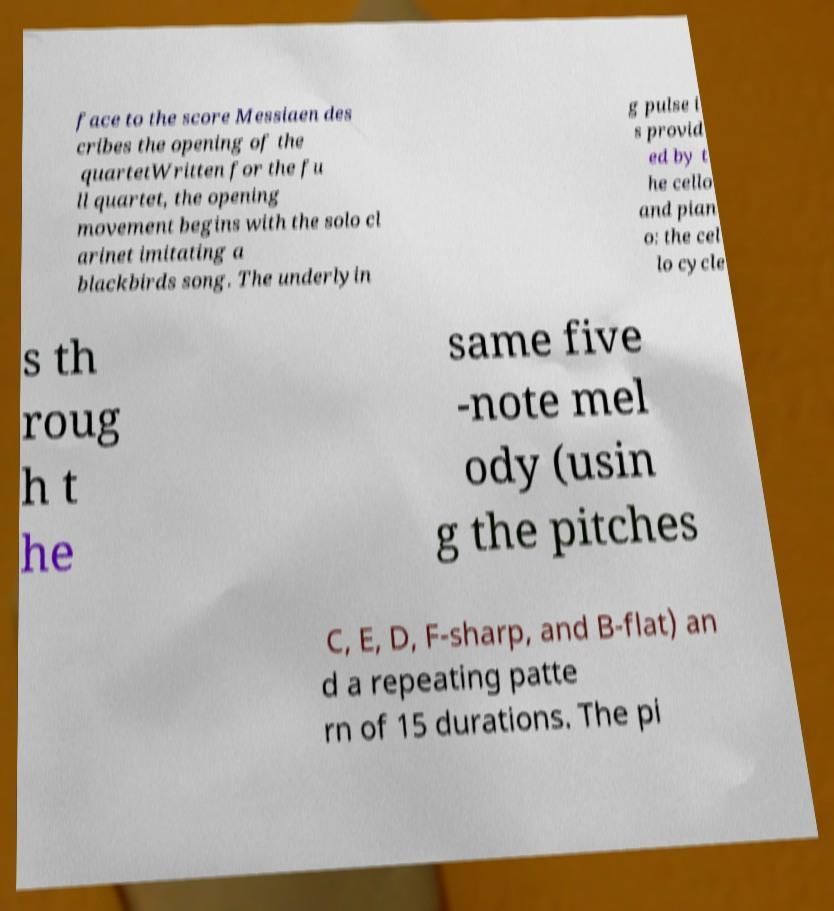Could you assist in decoding the text presented in this image and type it out clearly? face to the score Messiaen des cribes the opening of the quartetWritten for the fu ll quartet, the opening movement begins with the solo cl arinet imitating a blackbirds song. The underlyin g pulse i s provid ed by t he cello and pian o: the cel lo cycle s th roug h t he same five -note mel ody (usin g the pitches C, E, D, F-sharp, and B-flat) an d a repeating patte rn of 15 durations. The pi 